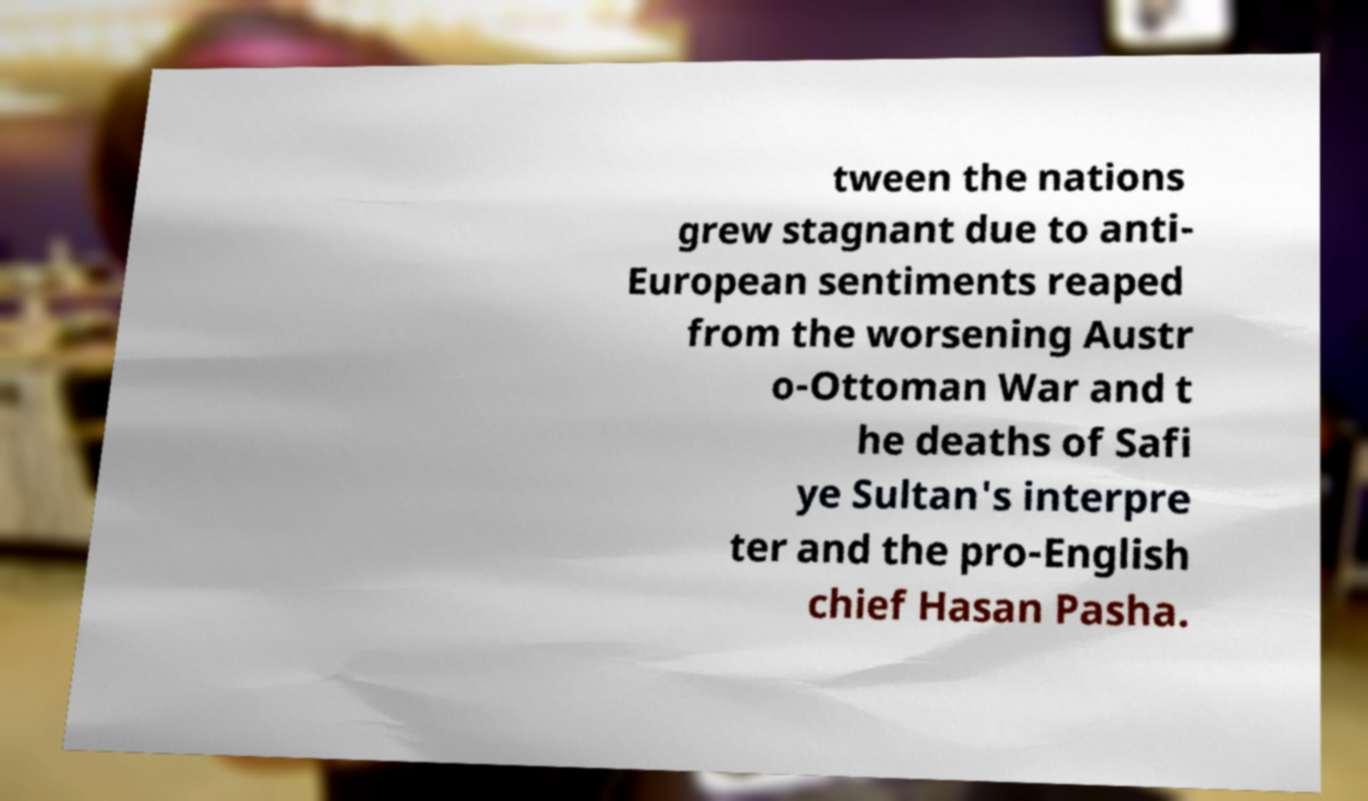Could you extract and type out the text from this image? tween the nations grew stagnant due to anti- European sentiments reaped from the worsening Austr o-Ottoman War and t he deaths of Safi ye Sultan's interpre ter and the pro-English chief Hasan Pasha. 